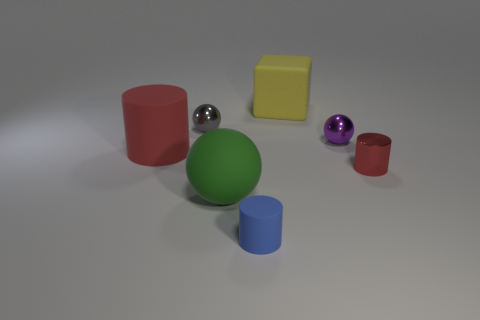Add 1 tiny blue rubber objects. How many objects exist? 8 Subtract all large red cylinders. How many cylinders are left? 2 Subtract all spheres. How many objects are left? 4 Subtract all tiny red rubber cubes. Subtract all large matte things. How many objects are left? 4 Add 1 shiny objects. How many shiny objects are left? 4 Add 6 blue objects. How many blue objects exist? 7 Subtract all blue cylinders. How many cylinders are left? 2 Subtract 1 gray balls. How many objects are left? 6 Subtract 2 cylinders. How many cylinders are left? 1 Subtract all gray balls. Subtract all red cylinders. How many balls are left? 2 